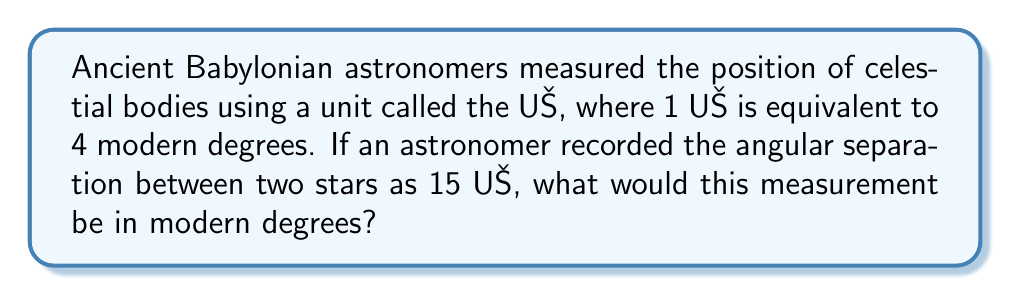Give your solution to this math problem. To solve this problem, we need to convert from the ancient Babylonian unit UŠ to modern degrees. Let's approach this step-by-step:

1. Establish the conversion ratio:
   $1 \text{ UŠ} = 4°$ (modern degrees)

2. Set up the conversion equation:
   Let $x$ be the number of modern degrees.
   $15 \text{ UŠ} = x°$

3. Use the conversion ratio to set up a proportion:
   $$\frac{1 \text{ UŠ}}{4°} = \frac{15 \text{ UŠ}}{x°}$$

4. Cross multiply:
   $$1 \cdot x = 4 \cdot 15$$

5. Solve for $x$:
   $$x = 4 \cdot 15 = 60$$

Therefore, 15 UŠ is equivalent to 60 modern degrees.
Answer: $60°$ 